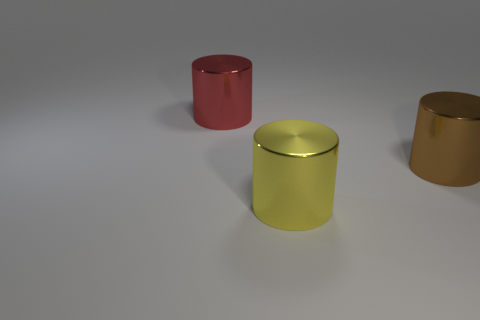Add 1 big red metallic cylinders. How many objects exist? 4 Subtract all tiny brown objects. Subtract all cylinders. How many objects are left? 0 Add 2 large yellow objects. How many large yellow objects are left? 3 Add 1 tiny yellow shiny spheres. How many tiny yellow shiny spheres exist? 1 Subtract 1 red cylinders. How many objects are left? 2 